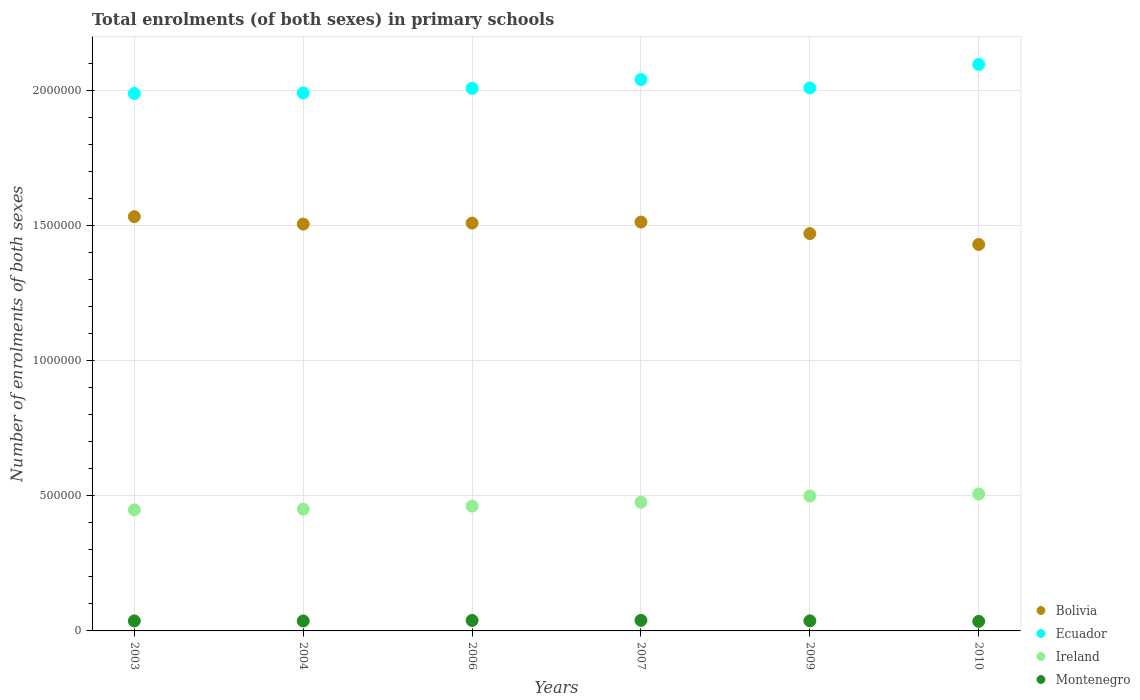How many different coloured dotlines are there?
Provide a succinct answer. 4. Is the number of dotlines equal to the number of legend labels?
Ensure brevity in your answer.  Yes. What is the number of enrolments in primary schools in Ireland in 2007?
Your response must be concise. 4.76e+05. Across all years, what is the maximum number of enrolments in primary schools in Bolivia?
Ensure brevity in your answer.  1.53e+06. Across all years, what is the minimum number of enrolments in primary schools in Ireland?
Your response must be concise. 4.48e+05. What is the total number of enrolments in primary schools in Ireland in the graph?
Your answer should be very brief. 2.84e+06. What is the difference between the number of enrolments in primary schools in Montenegro in 2004 and that in 2006?
Offer a terse response. -1947. What is the difference between the number of enrolments in primary schools in Ireland in 2009 and the number of enrolments in primary schools in Bolivia in 2010?
Offer a terse response. -9.30e+05. What is the average number of enrolments in primary schools in Bolivia per year?
Keep it short and to the point. 1.49e+06. In the year 2003, what is the difference between the number of enrolments in primary schools in Bolivia and number of enrolments in primary schools in Ecuador?
Offer a terse response. -4.55e+05. What is the ratio of the number of enrolments in primary schools in Ireland in 2006 to that in 2010?
Your answer should be compact. 0.91. What is the difference between the highest and the second highest number of enrolments in primary schools in Ecuador?
Offer a very short reply. 5.58e+04. What is the difference between the highest and the lowest number of enrolments in primary schools in Bolivia?
Your answer should be very brief. 1.03e+05. In how many years, is the number of enrolments in primary schools in Montenegro greater than the average number of enrolments in primary schools in Montenegro taken over all years?
Provide a succinct answer. 2. How many dotlines are there?
Ensure brevity in your answer.  4. What is the difference between two consecutive major ticks on the Y-axis?
Make the answer very short. 5.00e+05. Are the values on the major ticks of Y-axis written in scientific E-notation?
Give a very brief answer. No. Does the graph contain any zero values?
Provide a succinct answer. No. How many legend labels are there?
Ensure brevity in your answer.  4. How are the legend labels stacked?
Provide a short and direct response. Vertical. What is the title of the graph?
Give a very brief answer. Total enrolments (of both sexes) in primary schools. Does "Turkey" appear as one of the legend labels in the graph?
Provide a short and direct response. No. What is the label or title of the Y-axis?
Your response must be concise. Number of enrolments of both sexes. What is the Number of enrolments of both sexes in Bolivia in 2003?
Make the answer very short. 1.53e+06. What is the Number of enrolments of both sexes of Ecuador in 2003?
Give a very brief answer. 1.99e+06. What is the Number of enrolments of both sexes in Ireland in 2003?
Your answer should be very brief. 4.48e+05. What is the Number of enrolments of both sexes in Montenegro in 2003?
Make the answer very short. 3.70e+04. What is the Number of enrolments of both sexes in Bolivia in 2004?
Keep it short and to the point. 1.50e+06. What is the Number of enrolments of both sexes in Ecuador in 2004?
Your answer should be compact. 1.99e+06. What is the Number of enrolments of both sexes in Ireland in 2004?
Your response must be concise. 4.50e+05. What is the Number of enrolments of both sexes of Montenegro in 2004?
Provide a short and direct response. 3.68e+04. What is the Number of enrolments of both sexes in Bolivia in 2006?
Your answer should be very brief. 1.51e+06. What is the Number of enrolments of both sexes in Ecuador in 2006?
Offer a very short reply. 2.01e+06. What is the Number of enrolments of both sexes of Ireland in 2006?
Your answer should be compact. 4.62e+05. What is the Number of enrolments of both sexes of Montenegro in 2006?
Keep it short and to the point. 3.87e+04. What is the Number of enrolments of both sexes of Bolivia in 2007?
Offer a very short reply. 1.51e+06. What is the Number of enrolments of both sexes in Ecuador in 2007?
Make the answer very short. 2.04e+06. What is the Number of enrolments of both sexes of Ireland in 2007?
Provide a short and direct response. 4.76e+05. What is the Number of enrolments of both sexes of Montenegro in 2007?
Your answer should be very brief. 3.91e+04. What is the Number of enrolments of both sexes in Bolivia in 2009?
Give a very brief answer. 1.47e+06. What is the Number of enrolments of both sexes of Ecuador in 2009?
Provide a succinct answer. 2.01e+06. What is the Number of enrolments of both sexes in Ireland in 2009?
Provide a succinct answer. 4.99e+05. What is the Number of enrolments of both sexes of Montenegro in 2009?
Your answer should be compact. 3.73e+04. What is the Number of enrolments of both sexes in Bolivia in 2010?
Make the answer very short. 1.43e+06. What is the Number of enrolments of both sexes of Ecuador in 2010?
Your answer should be compact. 2.10e+06. What is the Number of enrolments of both sexes of Ireland in 2010?
Make the answer very short. 5.06e+05. What is the Number of enrolments of both sexes in Montenegro in 2010?
Make the answer very short. 3.53e+04. Across all years, what is the maximum Number of enrolments of both sexes of Bolivia?
Keep it short and to the point. 1.53e+06. Across all years, what is the maximum Number of enrolments of both sexes in Ecuador?
Keep it short and to the point. 2.10e+06. Across all years, what is the maximum Number of enrolments of both sexes of Ireland?
Offer a terse response. 5.06e+05. Across all years, what is the maximum Number of enrolments of both sexes of Montenegro?
Your response must be concise. 3.91e+04. Across all years, what is the minimum Number of enrolments of both sexes in Bolivia?
Your response must be concise. 1.43e+06. Across all years, what is the minimum Number of enrolments of both sexes of Ecuador?
Provide a short and direct response. 1.99e+06. Across all years, what is the minimum Number of enrolments of both sexes of Ireland?
Offer a very short reply. 4.48e+05. Across all years, what is the minimum Number of enrolments of both sexes in Montenegro?
Your answer should be compact. 3.53e+04. What is the total Number of enrolments of both sexes of Bolivia in the graph?
Your answer should be very brief. 8.96e+06. What is the total Number of enrolments of both sexes in Ecuador in the graph?
Keep it short and to the point. 1.21e+07. What is the total Number of enrolments of both sexes of Ireland in the graph?
Make the answer very short. 2.84e+06. What is the total Number of enrolments of both sexes of Montenegro in the graph?
Keep it short and to the point. 2.24e+05. What is the difference between the Number of enrolments of both sexes in Bolivia in 2003 and that in 2004?
Provide a short and direct response. 2.75e+04. What is the difference between the Number of enrolments of both sexes in Ecuador in 2003 and that in 2004?
Provide a succinct answer. -2200. What is the difference between the Number of enrolments of both sexes of Ireland in 2003 and that in 2004?
Your answer should be compact. -2795. What is the difference between the Number of enrolments of both sexes of Montenegro in 2003 and that in 2004?
Ensure brevity in your answer.  216. What is the difference between the Number of enrolments of both sexes in Bolivia in 2003 and that in 2006?
Keep it short and to the point. 2.38e+04. What is the difference between the Number of enrolments of both sexes of Ecuador in 2003 and that in 2006?
Your response must be concise. -1.90e+04. What is the difference between the Number of enrolments of both sexes in Ireland in 2003 and that in 2006?
Provide a short and direct response. -1.40e+04. What is the difference between the Number of enrolments of both sexes in Montenegro in 2003 and that in 2006?
Give a very brief answer. -1731. What is the difference between the Number of enrolments of both sexes in Bolivia in 2003 and that in 2007?
Keep it short and to the point. 2.00e+04. What is the difference between the Number of enrolments of both sexes in Ecuador in 2003 and that in 2007?
Your answer should be compact. -5.17e+04. What is the difference between the Number of enrolments of both sexes in Ireland in 2003 and that in 2007?
Your response must be concise. -2.82e+04. What is the difference between the Number of enrolments of both sexes in Montenegro in 2003 and that in 2007?
Your response must be concise. -2114. What is the difference between the Number of enrolments of both sexes of Bolivia in 2003 and that in 2009?
Your response must be concise. 6.25e+04. What is the difference between the Number of enrolments of both sexes in Ecuador in 2003 and that in 2009?
Offer a very short reply. -2.06e+04. What is the difference between the Number of enrolments of both sexes of Ireland in 2003 and that in 2009?
Provide a succinct answer. -5.12e+04. What is the difference between the Number of enrolments of both sexes of Montenegro in 2003 and that in 2009?
Your answer should be very brief. -260. What is the difference between the Number of enrolments of both sexes of Bolivia in 2003 and that in 2010?
Keep it short and to the point. 1.03e+05. What is the difference between the Number of enrolments of both sexes in Ecuador in 2003 and that in 2010?
Provide a short and direct response. -1.08e+05. What is the difference between the Number of enrolments of both sexes of Ireland in 2003 and that in 2010?
Keep it short and to the point. -5.88e+04. What is the difference between the Number of enrolments of both sexes in Montenegro in 2003 and that in 2010?
Offer a terse response. 1745. What is the difference between the Number of enrolments of both sexes in Bolivia in 2004 and that in 2006?
Your answer should be compact. -3701. What is the difference between the Number of enrolments of both sexes in Ecuador in 2004 and that in 2006?
Offer a terse response. -1.68e+04. What is the difference between the Number of enrolments of both sexes in Ireland in 2004 and that in 2006?
Your answer should be very brief. -1.12e+04. What is the difference between the Number of enrolments of both sexes in Montenegro in 2004 and that in 2006?
Your answer should be very brief. -1947. What is the difference between the Number of enrolments of both sexes of Bolivia in 2004 and that in 2007?
Keep it short and to the point. -7509. What is the difference between the Number of enrolments of both sexes in Ecuador in 2004 and that in 2007?
Provide a succinct answer. -4.95e+04. What is the difference between the Number of enrolments of both sexes of Ireland in 2004 and that in 2007?
Give a very brief answer. -2.54e+04. What is the difference between the Number of enrolments of both sexes of Montenegro in 2004 and that in 2007?
Your answer should be very brief. -2330. What is the difference between the Number of enrolments of both sexes in Bolivia in 2004 and that in 2009?
Give a very brief answer. 3.50e+04. What is the difference between the Number of enrolments of both sexes in Ecuador in 2004 and that in 2009?
Your answer should be very brief. -1.84e+04. What is the difference between the Number of enrolments of both sexes in Ireland in 2004 and that in 2009?
Your response must be concise. -4.84e+04. What is the difference between the Number of enrolments of both sexes of Montenegro in 2004 and that in 2009?
Provide a succinct answer. -476. What is the difference between the Number of enrolments of both sexes of Bolivia in 2004 and that in 2010?
Offer a terse response. 7.54e+04. What is the difference between the Number of enrolments of both sexes in Ecuador in 2004 and that in 2010?
Offer a very short reply. -1.05e+05. What is the difference between the Number of enrolments of both sexes in Ireland in 2004 and that in 2010?
Your answer should be very brief. -5.60e+04. What is the difference between the Number of enrolments of both sexes of Montenegro in 2004 and that in 2010?
Keep it short and to the point. 1529. What is the difference between the Number of enrolments of both sexes in Bolivia in 2006 and that in 2007?
Your response must be concise. -3808. What is the difference between the Number of enrolments of both sexes of Ecuador in 2006 and that in 2007?
Offer a very short reply. -3.27e+04. What is the difference between the Number of enrolments of both sexes in Ireland in 2006 and that in 2007?
Provide a succinct answer. -1.42e+04. What is the difference between the Number of enrolments of both sexes in Montenegro in 2006 and that in 2007?
Your answer should be compact. -383. What is the difference between the Number of enrolments of both sexes in Bolivia in 2006 and that in 2009?
Offer a terse response. 3.87e+04. What is the difference between the Number of enrolments of both sexes in Ecuador in 2006 and that in 2009?
Your answer should be compact. -1585. What is the difference between the Number of enrolments of both sexes of Ireland in 2006 and that in 2009?
Offer a very short reply. -3.72e+04. What is the difference between the Number of enrolments of both sexes of Montenegro in 2006 and that in 2009?
Keep it short and to the point. 1471. What is the difference between the Number of enrolments of both sexes of Bolivia in 2006 and that in 2010?
Offer a very short reply. 7.91e+04. What is the difference between the Number of enrolments of both sexes of Ecuador in 2006 and that in 2010?
Provide a succinct answer. -8.86e+04. What is the difference between the Number of enrolments of both sexes in Ireland in 2006 and that in 2010?
Provide a short and direct response. -4.48e+04. What is the difference between the Number of enrolments of both sexes of Montenegro in 2006 and that in 2010?
Provide a short and direct response. 3476. What is the difference between the Number of enrolments of both sexes in Bolivia in 2007 and that in 2009?
Provide a succinct answer. 4.25e+04. What is the difference between the Number of enrolments of both sexes in Ecuador in 2007 and that in 2009?
Offer a very short reply. 3.12e+04. What is the difference between the Number of enrolments of both sexes of Ireland in 2007 and that in 2009?
Keep it short and to the point. -2.30e+04. What is the difference between the Number of enrolments of both sexes in Montenegro in 2007 and that in 2009?
Provide a succinct answer. 1854. What is the difference between the Number of enrolments of both sexes in Bolivia in 2007 and that in 2010?
Give a very brief answer. 8.29e+04. What is the difference between the Number of enrolments of both sexes in Ecuador in 2007 and that in 2010?
Ensure brevity in your answer.  -5.58e+04. What is the difference between the Number of enrolments of both sexes in Ireland in 2007 and that in 2010?
Offer a terse response. -3.06e+04. What is the difference between the Number of enrolments of both sexes in Montenegro in 2007 and that in 2010?
Offer a very short reply. 3859. What is the difference between the Number of enrolments of both sexes in Bolivia in 2009 and that in 2010?
Your answer should be compact. 4.04e+04. What is the difference between the Number of enrolments of both sexes in Ecuador in 2009 and that in 2010?
Your answer should be compact. -8.70e+04. What is the difference between the Number of enrolments of both sexes of Ireland in 2009 and that in 2010?
Provide a succinct answer. -7562. What is the difference between the Number of enrolments of both sexes of Montenegro in 2009 and that in 2010?
Keep it short and to the point. 2005. What is the difference between the Number of enrolments of both sexes in Bolivia in 2003 and the Number of enrolments of both sexes in Ecuador in 2004?
Offer a very short reply. -4.58e+05. What is the difference between the Number of enrolments of both sexes in Bolivia in 2003 and the Number of enrolments of both sexes in Ireland in 2004?
Ensure brevity in your answer.  1.08e+06. What is the difference between the Number of enrolments of both sexes in Bolivia in 2003 and the Number of enrolments of both sexes in Montenegro in 2004?
Offer a very short reply. 1.50e+06. What is the difference between the Number of enrolments of both sexes in Ecuador in 2003 and the Number of enrolments of both sexes in Ireland in 2004?
Your response must be concise. 1.54e+06. What is the difference between the Number of enrolments of both sexes in Ecuador in 2003 and the Number of enrolments of both sexes in Montenegro in 2004?
Provide a short and direct response. 1.95e+06. What is the difference between the Number of enrolments of both sexes in Ireland in 2003 and the Number of enrolments of both sexes in Montenegro in 2004?
Offer a very short reply. 4.11e+05. What is the difference between the Number of enrolments of both sexes of Bolivia in 2003 and the Number of enrolments of both sexes of Ecuador in 2006?
Your answer should be compact. -4.74e+05. What is the difference between the Number of enrolments of both sexes in Bolivia in 2003 and the Number of enrolments of both sexes in Ireland in 2006?
Your response must be concise. 1.07e+06. What is the difference between the Number of enrolments of both sexes of Bolivia in 2003 and the Number of enrolments of both sexes of Montenegro in 2006?
Keep it short and to the point. 1.49e+06. What is the difference between the Number of enrolments of both sexes in Ecuador in 2003 and the Number of enrolments of both sexes in Ireland in 2006?
Keep it short and to the point. 1.53e+06. What is the difference between the Number of enrolments of both sexes in Ecuador in 2003 and the Number of enrolments of both sexes in Montenegro in 2006?
Provide a short and direct response. 1.95e+06. What is the difference between the Number of enrolments of both sexes in Ireland in 2003 and the Number of enrolments of both sexes in Montenegro in 2006?
Make the answer very short. 4.09e+05. What is the difference between the Number of enrolments of both sexes of Bolivia in 2003 and the Number of enrolments of both sexes of Ecuador in 2007?
Your response must be concise. -5.07e+05. What is the difference between the Number of enrolments of both sexes of Bolivia in 2003 and the Number of enrolments of both sexes of Ireland in 2007?
Your answer should be compact. 1.06e+06. What is the difference between the Number of enrolments of both sexes of Bolivia in 2003 and the Number of enrolments of both sexes of Montenegro in 2007?
Provide a short and direct response. 1.49e+06. What is the difference between the Number of enrolments of both sexes in Ecuador in 2003 and the Number of enrolments of both sexes in Ireland in 2007?
Offer a very short reply. 1.51e+06. What is the difference between the Number of enrolments of both sexes in Ecuador in 2003 and the Number of enrolments of both sexes in Montenegro in 2007?
Your answer should be very brief. 1.95e+06. What is the difference between the Number of enrolments of both sexes in Ireland in 2003 and the Number of enrolments of both sexes in Montenegro in 2007?
Make the answer very short. 4.08e+05. What is the difference between the Number of enrolments of both sexes in Bolivia in 2003 and the Number of enrolments of both sexes in Ecuador in 2009?
Offer a terse response. -4.76e+05. What is the difference between the Number of enrolments of both sexes of Bolivia in 2003 and the Number of enrolments of both sexes of Ireland in 2009?
Offer a very short reply. 1.03e+06. What is the difference between the Number of enrolments of both sexes of Bolivia in 2003 and the Number of enrolments of both sexes of Montenegro in 2009?
Ensure brevity in your answer.  1.49e+06. What is the difference between the Number of enrolments of both sexes in Ecuador in 2003 and the Number of enrolments of both sexes in Ireland in 2009?
Offer a very short reply. 1.49e+06. What is the difference between the Number of enrolments of both sexes in Ecuador in 2003 and the Number of enrolments of both sexes in Montenegro in 2009?
Your answer should be compact. 1.95e+06. What is the difference between the Number of enrolments of both sexes in Ireland in 2003 and the Number of enrolments of both sexes in Montenegro in 2009?
Offer a terse response. 4.10e+05. What is the difference between the Number of enrolments of both sexes of Bolivia in 2003 and the Number of enrolments of both sexes of Ecuador in 2010?
Provide a short and direct response. -5.63e+05. What is the difference between the Number of enrolments of both sexes in Bolivia in 2003 and the Number of enrolments of both sexes in Ireland in 2010?
Your answer should be very brief. 1.03e+06. What is the difference between the Number of enrolments of both sexes in Bolivia in 2003 and the Number of enrolments of both sexes in Montenegro in 2010?
Your answer should be very brief. 1.50e+06. What is the difference between the Number of enrolments of both sexes of Ecuador in 2003 and the Number of enrolments of both sexes of Ireland in 2010?
Your answer should be very brief. 1.48e+06. What is the difference between the Number of enrolments of both sexes in Ecuador in 2003 and the Number of enrolments of both sexes in Montenegro in 2010?
Give a very brief answer. 1.95e+06. What is the difference between the Number of enrolments of both sexes of Ireland in 2003 and the Number of enrolments of both sexes of Montenegro in 2010?
Your answer should be compact. 4.12e+05. What is the difference between the Number of enrolments of both sexes in Bolivia in 2004 and the Number of enrolments of both sexes in Ecuador in 2006?
Offer a terse response. -5.02e+05. What is the difference between the Number of enrolments of both sexes of Bolivia in 2004 and the Number of enrolments of both sexes of Ireland in 2006?
Your answer should be very brief. 1.04e+06. What is the difference between the Number of enrolments of both sexes in Bolivia in 2004 and the Number of enrolments of both sexes in Montenegro in 2006?
Offer a very short reply. 1.47e+06. What is the difference between the Number of enrolments of both sexes in Ecuador in 2004 and the Number of enrolments of both sexes in Ireland in 2006?
Make the answer very short. 1.53e+06. What is the difference between the Number of enrolments of both sexes of Ecuador in 2004 and the Number of enrolments of both sexes of Montenegro in 2006?
Give a very brief answer. 1.95e+06. What is the difference between the Number of enrolments of both sexes in Ireland in 2004 and the Number of enrolments of both sexes in Montenegro in 2006?
Provide a succinct answer. 4.12e+05. What is the difference between the Number of enrolments of both sexes in Bolivia in 2004 and the Number of enrolments of both sexes in Ecuador in 2007?
Give a very brief answer. -5.35e+05. What is the difference between the Number of enrolments of both sexes of Bolivia in 2004 and the Number of enrolments of both sexes of Ireland in 2007?
Offer a terse response. 1.03e+06. What is the difference between the Number of enrolments of both sexes of Bolivia in 2004 and the Number of enrolments of both sexes of Montenegro in 2007?
Ensure brevity in your answer.  1.47e+06. What is the difference between the Number of enrolments of both sexes in Ecuador in 2004 and the Number of enrolments of both sexes in Ireland in 2007?
Give a very brief answer. 1.51e+06. What is the difference between the Number of enrolments of both sexes in Ecuador in 2004 and the Number of enrolments of both sexes in Montenegro in 2007?
Your answer should be compact. 1.95e+06. What is the difference between the Number of enrolments of both sexes in Ireland in 2004 and the Number of enrolments of both sexes in Montenegro in 2007?
Make the answer very short. 4.11e+05. What is the difference between the Number of enrolments of both sexes of Bolivia in 2004 and the Number of enrolments of both sexes of Ecuador in 2009?
Keep it short and to the point. -5.04e+05. What is the difference between the Number of enrolments of both sexes of Bolivia in 2004 and the Number of enrolments of both sexes of Ireland in 2009?
Give a very brief answer. 1.01e+06. What is the difference between the Number of enrolments of both sexes in Bolivia in 2004 and the Number of enrolments of both sexes in Montenegro in 2009?
Offer a very short reply. 1.47e+06. What is the difference between the Number of enrolments of both sexes of Ecuador in 2004 and the Number of enrolments of both sexes of Ireland in 2009?
Provide a short and direct response. 1.49e+06. What is the difference between the Number of enrolments of both sexes in Ecuador in 2004 and the Number of enrolments of both sexes in Montenegro in 2009?
Offer a very short reply. 1.95e+06. What is the difference between the Number of enrolments of both sexes in Ireland in 2004 and the Number of enrolments of both sexes in Montenegro in 2009?
Ensure brevity in your answer.  4.13e+05. What is the difference between the Number of enrolments of both sexes of Bolivia in 2004 and the Number of enrolments of both sexes of Ecuador in 2010?
Make the answer very short. -5.91e+05. What is the difference between the Number of enrolments of both sexes of Bolivia in 2004 and the Number of enrolments of both sexes of Ireland in 2010?
Offer a very short reply. 9.98e+05. What is the difference between the Number of enrolments of both sexes in Bolivia in 2004 and the Number of enrolments of both sexes in Montenegro in 2010?
Make the answer very short. 1.47e+06. What is the difference between the Number of enrolments of both sexes of Ecuador in 2004 and the Number of enrolments of both sexes of Ireland in 2010?
Give a very brief answer. 1.48e+06. What is the difference between the Number of enrolments of both sexes in Ecuador in 2004 and the Number of enrolments of both sexes in Montenegro in 2010?
Provide a short and direct response. 1.95e+06. What is the difference between the Number of enrolments of both sexes of Ireland in 2004 and the Number of enrolments of both sexes of Montenegro in 2010?
Keep it short and to the point. 4.15e+05. What is the difference between the Number of enrolments of both sexes of Bolivia in 2006 and the Number of enrolments of both sexes of Ecuador in 2007?
Offer a terse response. -5.31e+05. What is the difference between the Number of enrolments of both sexes in Bolivia in 2006 and the Number of enrolments of both sexes in Ireland in 2007?
Keep it short and to the point. 1.03e+06. What is the difference between the Number of enrolments of both sexes of Bolivia in 2006 and the Number of enrolments of both sexes of Montenegro in 2007?
Your answer should be compact. 1.47e+06. What is the difference between the Number of enrolments of both sexes in Ecuador in 2006 and the Number of enrolments of both sexes in Ireland in 2007?
Your answer should be compact. 1.53e+06. What is the difference between the Number of enrolments of both sexes in Ecuador in 2006 and the Number of enrolments of both sexes in Montenegro in 2007?
Give a very brief answer. 1.97e+06. What is the difference between the Number of enrolments of both sexes in Ireland in 2006 and the Number of enrolments of both sexes in Montenegro in 2007?
Provide a short and direct response. 4.22e+05. What is the difference between the Number of enrolments of both sexes of Bolivia in 2006 and the Number of enrolments of both sexes of Ecuador in 2009?
Your answer should be compact. -5.00e+05. What is the difference between the Number of enrolments of both sexes of Bolivia in 2006 and the Number of enrolments of both sexes of Ireland in 2009?
Make the answer very short. 1.01e+06. What is the difference between the Number of enrolments of both sexes in Bolivia in 2006 and the Number of enrolments of both sexes in Montenegro in 2009?
Make the answer very short. 1.47e+06. What is the difference between the Number of enrolments of both sexes in Ecuador in 2006 and the Number of enrolments of both sexes in Ireland in 2009?
Keep it short and to the point. 1.51e+06. What is the difference between the Number of enrolments of both sexes in Ecuador in 2006 and the Number of enrolments of both sexes in Montenegro in 2009?
Your answer should be very brief. 1.97e+06. What is the difference between the Number of enrolments of both sexes in Ireland in 2006 and the Number of enrolments of both sexes in Montenegro in 2009?
Give a very brief answer. 4.24e+05. What is the difference between the Number of enrolments of both sexes in Bolivia in 2006 and the Number of enrolments of both sexes in Ecuador in 2010?
Ensure brevity in your answer.  -5.87e+05. What is the difference between the Number of enrolments of both sexes in Bolivia in 2006 and the Number of enrolments of both sexes in Ireland in 2010?
Your answer should be very brief. 1.00e+06. What is the difference between the Number of enrolments of both sexes of Bolivia in 2006 and the Number of enrolments of both sexes of Montenegro in 2010?
Offer a very short reply. 1.47e+06. What is the difference between the Number of enrolments of both sexes of Ecuador in 2006 and the Number of enrolments of both sexes of Ireland in 2010?
Ensure brevity in your answer.  1.50e+06. What is the difference between the Number of enrolments of both sexes in Ecuador in 2006 and the Number of enrolments of both sexes in Montenegro in 2010?
Give a very brief answer. 1.97e+06. What is the difference between the Number of enrolments of both sexes in Ireland in 2006 and the Number of enrolments of both sexes in Montenegro in 2010?
Provide a succinct answer. 4.26e+05. What is the difference between the Number of enrolments of both sexes in Bolivia in 2007 and the Number of enrolments of both sexes in Ecuador in 2009?
Offer a very short reply. -4.96e+05. What is the difference between the Number of enrolments of both sexes of Bolivia in 2007 and the Number of enrolments of both sexes of Ireland in 2009?
Your response must be concise. 1.01e+06. What is the difference between the Number of enrolments of both sexes of Bolivia in 2007 and the Number of enrolments of both sexes of Montenegro in 2009?
Make the answer very short. 1.47e+06. What is the difference between the Number of enrolments of both sexes of Ecuador in 2007 and the Number of enrolments of both sexes of Ireland in 2009?
Provide a short and direct response. 1.54e+06. What is the difference between the Number of enrolments of both sexes in Ecuador in 2007 and the Number of enrolments of both sexes in Montenegro in 2009?
Give a very brief answer. 2.00e+06. What is the difference between the Number of enrolments of both sexes in Ireland in 2007 and the Number of enrolments of both sexes in Montenegro in 2009?
Make the answer very short. 4.39e+05. What is the difference between the Number of enrolments of both sexes of Bolivia in 2007 and the Number of enrolments of both sexes of Ecuador in 2010?
Keep it short and to the point. -5.83e+05. What is the difference between the Number of enrolments of both sexes in Bolivia in 2007 and the Number of enrolments of both sexes in Ireland in 2010?
Provide a short and direct response. 1.01e+06. What is the difference between the Number of enrolments of both sexes in Bolivia in 2007 and the Number of enrolments of both sexes in Montenegro in 2010?
Your answer should be compact. 1.48e+06. What is the difference between the Number of enrolments of both sexes in Ecuador in 2007 and the Number of enrolments of both sexes in Ireland in 2010?
Give a very brief answer. 1.53e+06. What is the difference between the Number of enrolments of both sexes of Ecuador in 2007 and the Number of enrolments of both sexes of Montenegro in 2010?
Your answer should be very brief. 2.00e+06. What is the difference between the Number of enrolments of both sexes in Ireland in 2007 and the Number of enrolments of both sexes in Montenegro in 2010?
Give a very brief answer. 4.41e+05. What is the difference between the Number of enrolments of both sexes of Bolivia in 2009 and the Number of enrolments of both sexes of Ecuador in 2010?
Keep it short and to the point. -6.26e+05. What is the difference between the Number of enrolments of both sexes in Bolivia in 2009 and the Number of enrolments of both sexes in Ireland in 2010?
Ensure brevity in your answer.  9.63e+05. What is the difference between the Number of enrolments of both sexes in Bolivia in 2009 and the Number of enrolments of both sexes in Montenegro in 2010?
Your answer should be compact. 1.43e+06. What is the difference between the Number of enrolments of both sexes of Ecuador in 2009 and the Number of enrolments of both sexes of Ireland in 2010?
Offer a very short reply. 1.50e+06. What is the difference between the Number of enrolments of both sexes of Ecuador in 2009 and the Number of enrolments of both sexes of Montenegro in 2010?
Keep it short and to the point. 1.97e+06. What is the difference between the Number of enrolments of both sexes of Ireland in 2009 and the Number of enrolments of both sexes of Montenegro in 2010?
Your answer should be compact. 4.64e+05. What is the average Number of enrolments of both sexes in Bolivia per year?
Make the answer very short. 1.49e+06. What is the average Number of enrolments of both sexes in Ecuador per year?
Offer a terse response. 2.02e+06. What is the average Number of enrolments of both sexes in Ireland per year?
Offer a very short reply. 4.73e+05. What is the average Number of enrolments of both sexes of Montenegro per year?
Ensure brevity in your answer.  3.74e+04. In the year 2003, what is the difference between the Number of enrolments of both sexes in Bolivia and Number of enrolments of both sexes in Ecuador?
Offer a terse response. -4.55e+05. In the year 2003, what is the difference between the Number of enrolments of both sexes of Bolivia and Number of enrolments of both sexes of Ireland?
Provide a short and direct response. 1.08e+06. In the year 2003, what is the difference between the Number of enrolments of both sexes of Bolivia and Number of enrolments of both sexes of Montenegro?
Your answer should be very brief. 1.49e+06. In the year 2003, what is the difference between the Number of enrolments of both sexes in Ecuador and Number of enrolments of both sexes in Ireland?
Keep it short and to the point. 1.54e+06. In the year 2003, what is the difference between the Number of enrolments of both sexes in Ecuador and Number of enrolments of both sexes in Montenegro?
Keep it short and to the point. 1.95e+06. In the year 2003, what is the difference between the Number of enrolments of both sexes in Ireland and Number of enrolments of both sexes in Montenegro?
Ensure brevity in your answer.  4.11e+05. In the year 2004, what is the difference between the Number of enrolments of both sexes of Bolivia and Number of enrolments of both sexes of Ecuador?
Provide a short and direct response. -4.85e+05. In the year 2004, what is the difference between the Number of enrolments of both sexes in Bolivia and Number of enrolments of both sexes in Ireland?
Provide a short and direct response. 1.05e+06. In the year 2004, what is the difference between the Number of enrolments of both sexes in Bolivia and Number of enrolments of both sexes in Montenegro?
Offer a terse response. 1.47e+06. In the year 2004, what is the difference between the Number of enrolments of both sexes of Ecuador and Number of enrolments of both sexes of Ireland?
Offer a terse response. 1.54e+06. In the year 2004, what is the difference between the Number of enrolments of both sexes in Ecuador and Number of enrolments of both sexes in Montenegro?
Your response must be concise. 1.95e+06. In the year 2004, what is the difference between the Number of enrolments of both sexes of Ireland and Number of enrolments of both sexes of Montenegro?
Provide a succinct answer. 4.14e+05. In the year 2006, what is the difference between the Number of enrolments of both sexes of Bolivia and Number of enrolments of both sexes of Ecuador?
Provide a succinct answer. -4.98e+05. In the year 2006, what is the difference between the Number of enrolments of both sexes in Bolivia and Number of enrolments of both sexes in Ireland?
Provide a succinct answer. 1.05e+06. In the year 2006, what is the difference between the Number of enrolments of both sexes in Bolivia and Number of enrolments of both sexes in Montenegro?
Provide a succinct answer. 1.47e+06. In the year 2006, what is the difference between the Number of enrolments of both sexes of Ecuador and Number of enrolments of both sexes of Ireland?
Provide a succinct answer. 1.54e+06. In the year 2006, what is the difference between the Number of enrolments of both sexes in Ecuador and Number of enrolments of both sexes in Montenegro?
Your response must be concise. 1.97e+06. In the year 2006, what is the difference between the Number of enrolments of both sexes of Ireland and Number of enrolments of both sexes of Montenegro?
Your answer should be compact. 4.23e+05. In the year 2007, what is the difference between the Number of enrolments of both sexes in Bolivia and Number of enrolments of both sexes in Ecuador?
Ensure brevity in your answer.  -5.27e+05. In the year 2007, what is the difference between the Number of enrolments of both sexes in Bolivia and Number of enrolments of both sexes in Ireland?
Provide a succinct answer. 1.04e+06. In the year 2007, what is the difference between the Number of enrolments of both sexes of Bolivia and Number of enrolments of both sexes of Montenegro?
Provide a succinct answer. 1.47e+06. In the year 2007, what is the difference between the Number of enrolments of both sexes of Ecuador and Number of enrolments of both sexes of Ireland?
Your answer should be compact. 1.56e+06. In the year 2007, what is the difference between the Number of enrolments of both sexes in Ecuador and Number of enrolments of both sexes in Montenegro?
Your response must be concise. 2.00e+06. In the year 2007, what is the difference between the Number of enrolments of both sexes in Ireland and Number of enrolments of both sexes in Montenegro?
Your answer should be very brief. 4.37e+05. In the year 2009, what is the difference between the Number of enrolments of both sexes of Bolivia and Number of enrolments of both sexes of Ecuador?
Give a very brief answer. -5.39e+05. In the year 2009, what is the difference between the Number of enrolments of both sexes in Bolivia and Number of enrolments of both sexes in Ireland?
Provide a succinct answer. 9.71e+05. In the year 2009, what is the difference between the Number of enrolments of both sexes in Bolivia and Number of enrolments of both sexes in Montenegro?
Your answer should be very brief. 1.43e+06. In the year 2009, what is the difference between the Number of enrolments of both sexes in Ecuador and Number of enrolments of both sexes in Ireland?
Your response must be concise. 1.51e+06. In the year 2009, what is the difference between the Number of enrolments of both sexes of Ecuador and Number of enrolments of both sexes of Montenegro?
Provide a short and direct response. 1.97e+06. In the year 2009, what is the difference between the Number of enrolments of both sexes in Ireland and Number of enrolments of both sexes in Montenegro?
Offer a terse response. 4.62e+05. In the year 2010, what is the difference between the Number of enrolments of both sexes in Bolivia and Number of enrolments of both sexes in Ecuador?
Your response must be concise. -6.66e+05. In the year 2010, what is the difference between the Number of enrolments of both sexes in Bolivia and Number of enrolments of both sexes in Ireland?
Give a very brief answer. 9.23e+05. In the year 2010, what is the difference between the Number of enrolments of both sexes in Bolivia and Number of enrolments of both sexes in Montenegro?
Provide a short and direct response. 1.39e+06. In the year 2010, what is the difference between the Number of enrolments of both sexes in Ecuador and Number of enrolments of both sexes in Ireland?
Your answer should be very brief. 1.59e+06. In the year 2010, what is the difference between the Number of enrolments of both sexes of Ecuador and Number of enrolments of both sexes of Montenegro?
Your answer should be very brief. 2.06e+06. In the year 2010, what is the difference between the Number of enrolments of both sexes in Ireland and Number of enrolments of both sexes in Montenegro?
Keep it short and to the point. 4.71e+05. What is the ratio of the Number of enrolments of both sexes in Bolivia in 2003 to that in 2004?
Offer a terse response. 1.02. What is the ratio of the Number of enrolments of both sexes of Ecuador in 2003 to that in 2004?
Your answer should be compact. 1. What is the ratio of the Number of enrolments of both sexes of Ireland in 2003 to that in 2004?
Ensure brevity in your answer.  0.99. What is the ratio of the Number of enrolments of both sexes in Montenegro in 2003 to that in 2004?
Your answer should be very brief. 1.01. What is the ratio of the Number of enrolments of both sexes in Bolivia in 2003 to that in 2006?
Give a very brief answer. 1.02. What is the ratio of the Number of enrolments of both sexes in Ecuador in 2003 to that in 2006?
Your response must be concise. 0.99. What is the ratio of the Number of enrolments of both sexes in Ireland in 2003 to that in 2006?
Provide a short and direct response. 0.97. What is the ratio of the Number of enrolments of both sexes of Montenegro in 2003 to that in 2006?
Ensure brevity in your answer.  0.96. What is the ratio of the Number of enrolments of both sexes of Bolivia in 2003 to that in 2007?
Offer a terse response. 1.01. What is the ratio of the Number of enrolments of both sexes of Ecuador in 2003 to that in 2007?
Your answer should be very brief. 0.97. What is the ratio of the Number of enrolments of both sexes in Ireland in 2003 to that in 2007?
Your answer should be compact. 0.94. What is the ratio of the Number of enrolments of both sexes of Montenegro in 2003 to that in 2007?
Your answer should be compact. 0.95. What is the ratio of the Number of enrolments of both sexes in Bolivia in 2003 to that in 2009?
Your answer should be very brief. 1.04. What is the ratio of the Number of enrolments of both sexes in Ecuador in 2003 to that in 2009?
Provide a short and direct response. 0.99. What is the ratio of the Number of enrolments of both sexes of Ireland in 2003 to that in 2009?
Keep it short and to the point. 0.9. What is the ratio of the Number of enrolments of both sexes in Bolivia in 2003 to that in 2010?
Offer a terse response. 1.07. What is the ratio of the Number of enrolments of both sexes in Ecuador in 2003 to that in 2010?
Keep it short and to the point. 0.95. What is the ratio of the Number of enrolments of both sexes of Ireland in 2003 to that in 2010?
Provide a short and direct response. 0.88. What is the ratio of the Number of enrolments of both sexes of Montenegro in 2003 to that in 2010?
Make the answer very short. 1.05. What is the ratio of the Number of enrolments of both sexes of Ecuador in 2004 to that in 2006?
Ensure brevity in your answer.  0.99. What is the ratio of the Number of enrolments of both sexes in Ireland in 2004 to that in 2006?
Make the answer very short. 0.98. What is the ratio of the Number of enrolments of both sexes of Montenegro in 2004 to that in 2006?
Keep it short and to the point. 0.95. What is the ratio of the Number of enrolments of both sexes of Bolivia in 2004 to that in 2007?
Your response must be concise. 0.99. What is the ratio of the Number of enrolments of both sexes of Ecuador in 2004 to that in 2007?
Keep it short and to the point. 0.98. What is the ratio of the Number of enrolments of both sexes of Ireland in 2004 to that in 2007?
Provide a succinct answer. 0.95. What is the ratio of the Number of enrolments of both sexes in Montenegro in 2004 to that in 2007?
Keep it short and to the point. 0.94. What is the ratio of the Number of enrolments of both sexes in Bolivia in 2004 to that in 2009?
Keep it short and to the point. 1.02. What is the ratio of the Number of enrolments of both sexes of Ecuador in 2004 to that in 2009?
Offer a terse response. 0.99. What is the ratio of the Number of enrolments of both sexes in Ireland in 2004 to that in 2009?
Offer a very short reply. 0.9. What is the ratio of the Number of enrolments of both sexes in Montenegro in 2004 to that in 2009?
Make the answer very short. 0.99. What is the ratio of the Number of enrolments of both sexes of Bolivia in 2004 to that in 2010?
Provide a succinct answer. 1.05. What is the ratio of the Number of enrolments of both sexes of Ecuador in 2004 to that in 2010?
Your response must be concise. 0.95. What is the ratio of the Number of enrolments of both sexes in Ireland in 2004 to that in 2010?
Offer a terse response. 0.89. What is the ratio of the Number of enrolments of both sexes of Montenegro in 2004 to that in 2010?
Your response must be concise. 1.04. What is the ratio of the Number of enrolments of both sexes of Bolivia in 2006 to that in 2007?
Your answer should be compact. 1. What is the ratio of the Number of enrolments of both sexes of Ecuador in 2006 to that in 2007?
Provide a succinct answer. 0.98. What is the ratio of the Number of enrolments of both sexes of Ireland in 2006 to that in 2007?
Your answer should be very brief. 0.97. What is the ratio of the Number of enrolments of both sexes in Montenegro in 2006 to that in 2007?
Offer a very short reply. 0.99. What is the ratio of the Number of enrolments of both sexes in Bolivia in 2006 to that in 2009?
Your answer should be very brief. 1.03. What is the ratio of the Number of enrolments of both sexes in Ecuador in 2006 to that in 2009?
Make the answer very short. 1. What is the ratio of the Number of enrolments of both sexes of Ireland in 2006 to that in 2009?
Your response must be concise. 0.93. What is the ratio of the Number of enrolments of both sexes of Montenegro in 2006 to that in 2009?
Make the answer very short. 1.04. What is the ratio of the Number of enrolments of both sexes in Bolivia in 2006 to that in 2010?
Your answer should be compact. 1.06. What is the ratio of the Number of enrolments of both sexes in Ecuador in 2006 to that in 2010?
Provide a succinct answer. 0.96. What is the ratio of the Number of enrolments of both sexes in Ireland in 2006 to that in 2010?
Provide a succinct answer. 0.91. What is the ratio of the Number of enrolments of both sexes in Montenegro in 2006 to that in 2010?
Your answer should be very brief. 1.1. What is the ratio of the Number of enrolments of both sexes of Bolivia in 2007 to that in 2009?
Keep it short and to the point. 1.03. What is the ratio of the Number of enrolments of both sexes in Ecuador in 2007 to that in 2009?
Your answer should be very brief. 1.02. What is the ratio of the Number of enrolments of both sexes in Ireland in 2007 to that in 2009?
Your answer should be very brief. 0.95. What is the ratio of the Number of enrolments of both sexes of Montenegro in 2007 to that in 2009?
Keep it short and to the point. 1.05. What is the ratio of the Number of enrolments of both sexes of Bolivia in 2007 to that in 2010?
Keep it short and to the point. 1.06. What is the ratio of the Number of enrolments of both sexes in Ecuador in 2007 to that in 2010?
Offer a very short reply. 0.97. What is the ratio of the Number of enrolments of both sexes of Ireland in 2007 to that in 2010?
Your response must be concise. 0.94. What is the ratio of the Number of enrolments of both sexes of Montenegro in 2007 to that in 2010?
Offer a very short reply. 1.11. What is the ratio of the Number of enrolments of both sexes of Bolivia in 2009 to that in 2010?
Keep it short and to the point. 1.03. What is the ratio of the Number of enrolments of both sexes in Ecuador in 2009 to that in 2010?
Provide a succinct answer. 0.96. What is the ratio of the Number of enrolments of both sexes of Ireland in 2009 to that in 2010?
Provide a succinct answer. 0.99. What is the ratio of the Number of enrolments of both sexes of Montenegro in 2009 to that in 2010?
Keep it short and to the point. 1.06. What is the difference between the highest and the second highest Number of enrolments of both sexes of Bolivia?
Your answer should be very brief. 2.00e+04. What is the difference between the highest and the second highest Number of enrolments of both sexes of Ecuador?
Make the answer very short. 5.58e+04. What is the difference between the highest and the second highest Number of enrolments of both sexes in Ireland?
Your answer should be very brief. 7562. What is the difference between the highest and the second highest Number of enrolments of both sexes in Montenegro?
Offer a terse response. 383. What is the difference between the highest and the lowest Number of enrolments of both sexes of Bolivia?
Your response must be concise. 1.03e+05. What is the difference between the highest and the lowest Number of enrolments of both sexes in Ecuador?
Give a very brief answer. 1.08e+05. What is the difference between the highest and the lowest Number of enrolments of both sexes of Ireland?
Ensure brevity in your answer.  5.88e+04. What is the difference between the highest and the lowest Number of enrolments of both sexes in Montenegro?
Your response must be concise. 3859. 